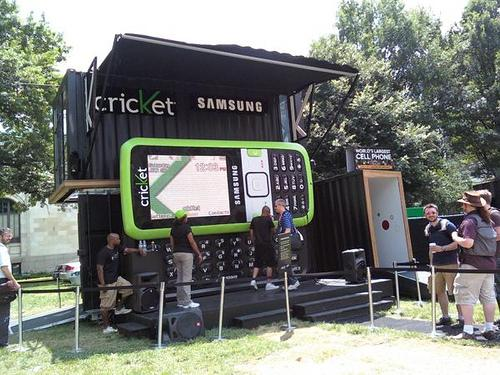Behance network has done most projects on which mobile? cricket 